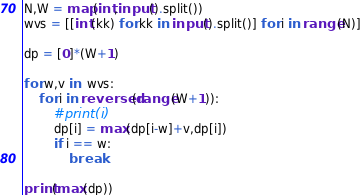<code> <loc_0><loc_0><loc_500><loc_500><_Python_>N,W = map(int,input().split())
wvs = [[int(kk) for kk in input().split()] for i in range(N)]

dp = [0]*(W+1)

for w,v in  wvs:
    for i in reversed(range(W+1)):
        #print(i)
        dp[i] = max(dp[i-w]+v,dp[i])
        if i == w:
            break

print(max(dp))

</code> 